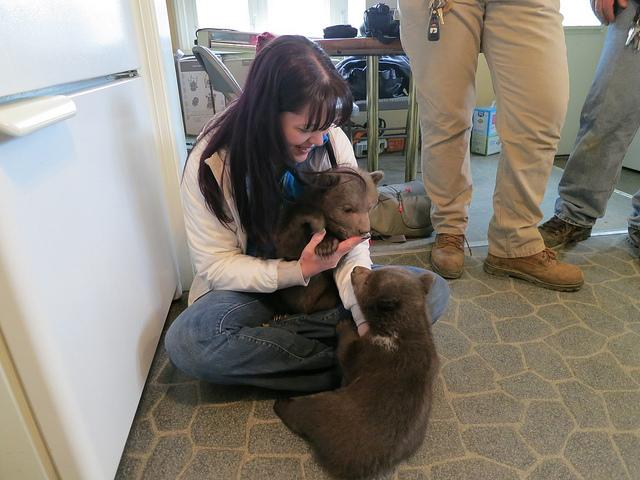What is she sitting next to on the left? refrigerator 